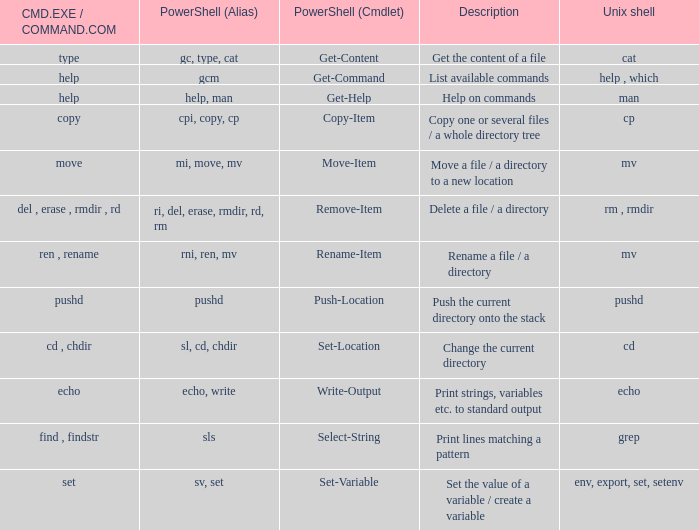How many values of powershell (cmdlet) are valid when unix shell is env, export, set, setenv? 1.0. 